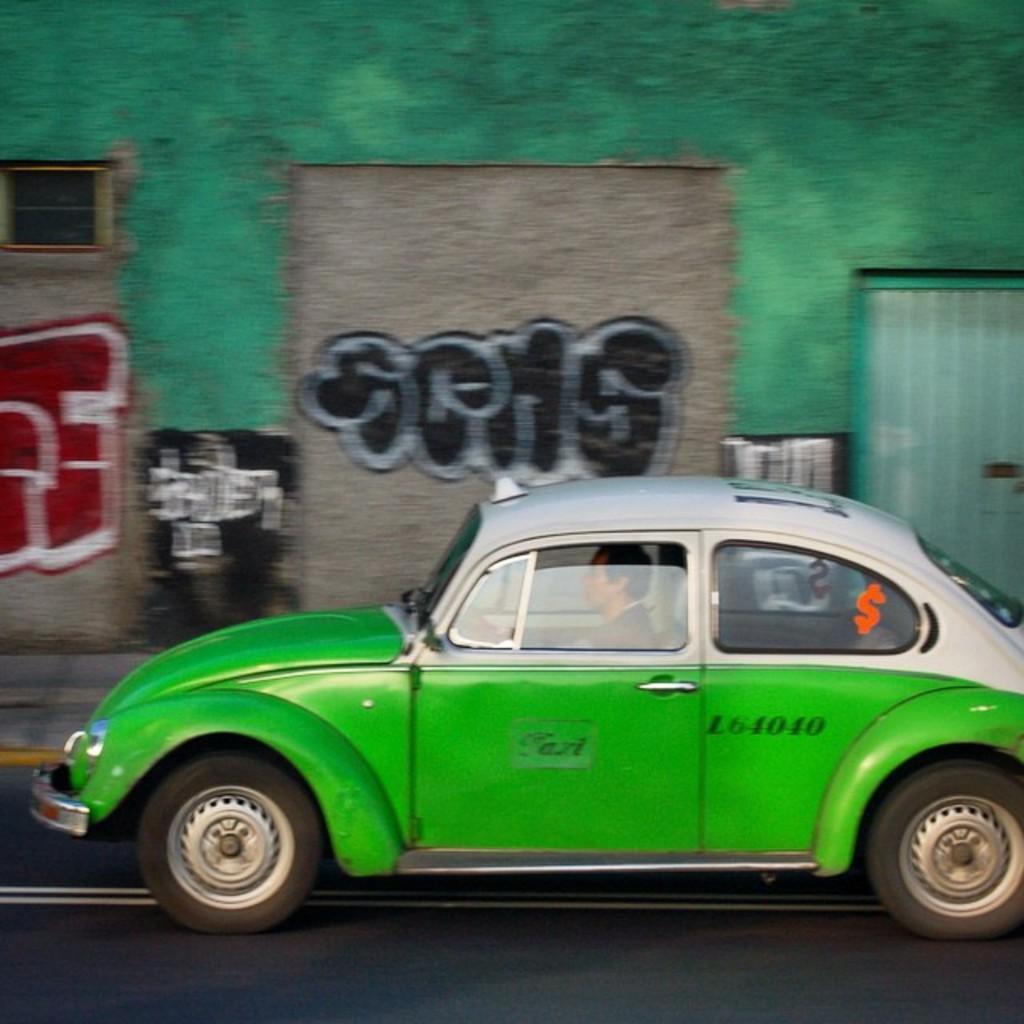Please provide a concise description of this image. In this image we can see a car which is of green color moving on the road and there is a person sitting in the car and at the background of the image there is green color wall. 